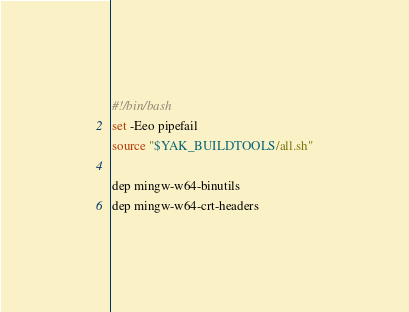<code> <loc_0><loc_0><loc_500><loc_500><_Bash_>#!/bin/bash
set -Eeo pipefail
source "$YAK_BUILDTOOLS/all.sh"

dep mingw-w64-binutils
dep mingw-w64-crt-headers
</code> 